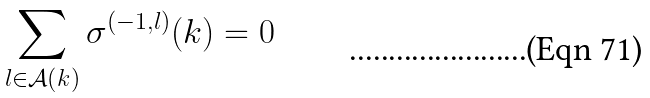<formula> <loc_0><loc_0><loc_500><loc_500>\sum _ { l \in \mathcal { A } ( k ) } \sigma ^ { ( - 1 , l ) } ( k ) = 0</formula> 